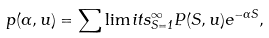<formula> <loc_0><loc_0><loc_500><loc_500>p ( \alpha , u ) = \sum \lim i t s _ { S = 1 } ^ { \infty } P ( S , u ) e ^ { - \alpha S } ,</formula> 